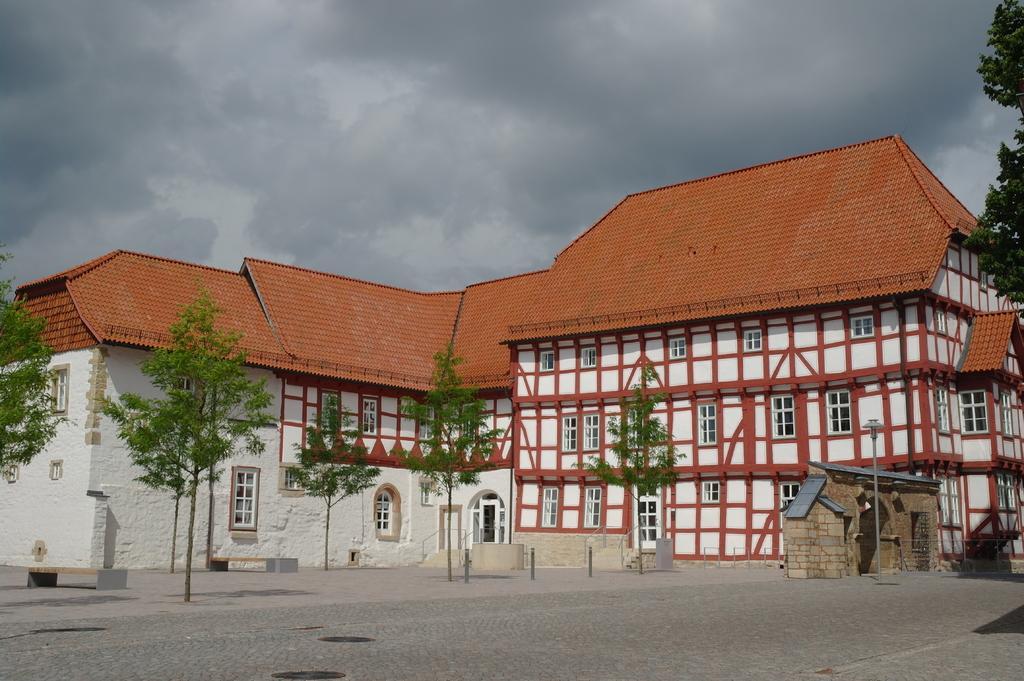Describe this image in one or two sentences. In this image there is a building in front of that there are some trees on the road. 